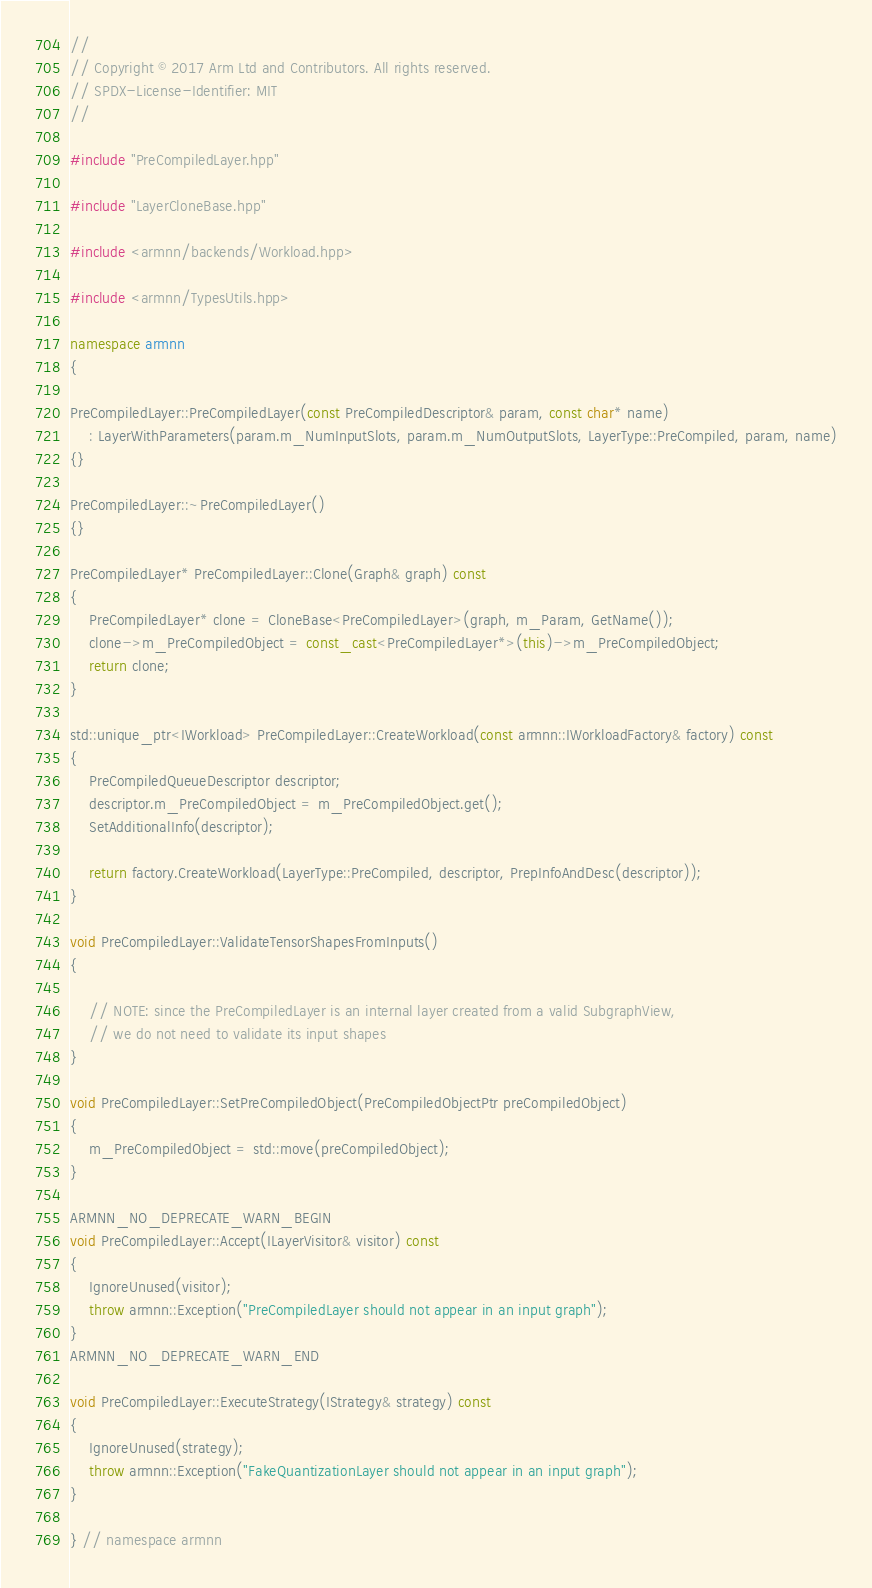<code> <loc_0><loc_0><loc_500><loc_500><_C++_>//
// Copyright © 2017 Arm Ltd and Contributors. All rights reserved.
// SPDX-License-Identifier: MIT
//

#include "PreCompiledLayer.hpp"

#include "LayerCloneBase.hpp"

#include <armnn/backends/Workload.hpp>

#include <armnn/TypesUtils.hpp>

namespace armnn
{

PreCompiledLayer::PreCompiledLayer(const PreCompiledDescriptor& param, const char* name)
    : LayerWithParameters(param.m_NumInputSlots, param.m_NumOutputSlots, LayerType::PreCompiled, param, name)
{}

PreCompiledLayer::~PreCompiledLayer()
{}

PreCompiledLayer* PreCompiledLayer::Clone(Graph& graph) const
{
    PreCompiledLayer* clone = CloneBase<PreCompiledLayer>(graph, m_Param, GetName());
    clone->m_PreCompiledObject = const_cast<PreCompiledLayer*>(this)->m_PreCompiledObject;
    return clone;
}

std::unique_ptr<IWorkload> PreCompiledLayer::CreateWorkload(const armnn::IWorkloadFactory& factory) const
{
    PreCompiledQueueDescriptor descriptor;
    descriptor.m_PreCompiledObject = m_PreCompiledObject.get();
    SetAdditionalInfo(descriptor);

    return factory.CreateWorkload(LayerType::PreCompiled, descriptor, PrepInfoAndDesc(descriptor));
}

void PreCompiledLayer::ValidateTensorShapesFromInputs()
{

    // NOTE: since the PreCompiledLayer is an internal layer created from a valid SubgraphView,
    // we do not need to validate its input shapes
}

void PreCompiledLayer::SetPreCompiledObject(PreCompiledObjectPtr preCompiledObject)
{
    m_PreCompiledObject = std::move(preCompiledObject);
}

ARMNN_NO_DEPRECATE_WARN_BEGIN
void PreCompiledLayer::Accept(ILayerVisitor& visitor) const
{
    IgnoreUnused(visitor);
    throw armnn::Exception("PreCompiledLayer should not appear in an input graph");
}
ARMNN_NO_DEPRECATE_WARN_END

void PreCompiledLayer::ExecuteStrategy(IStrategy& strategy) const
{
    IgnoreUnused(strategy);
    throw armnn::Exception("FakeQuantizationLayer should not appear in an input graph");
}

} // namespace armnn
</code> 